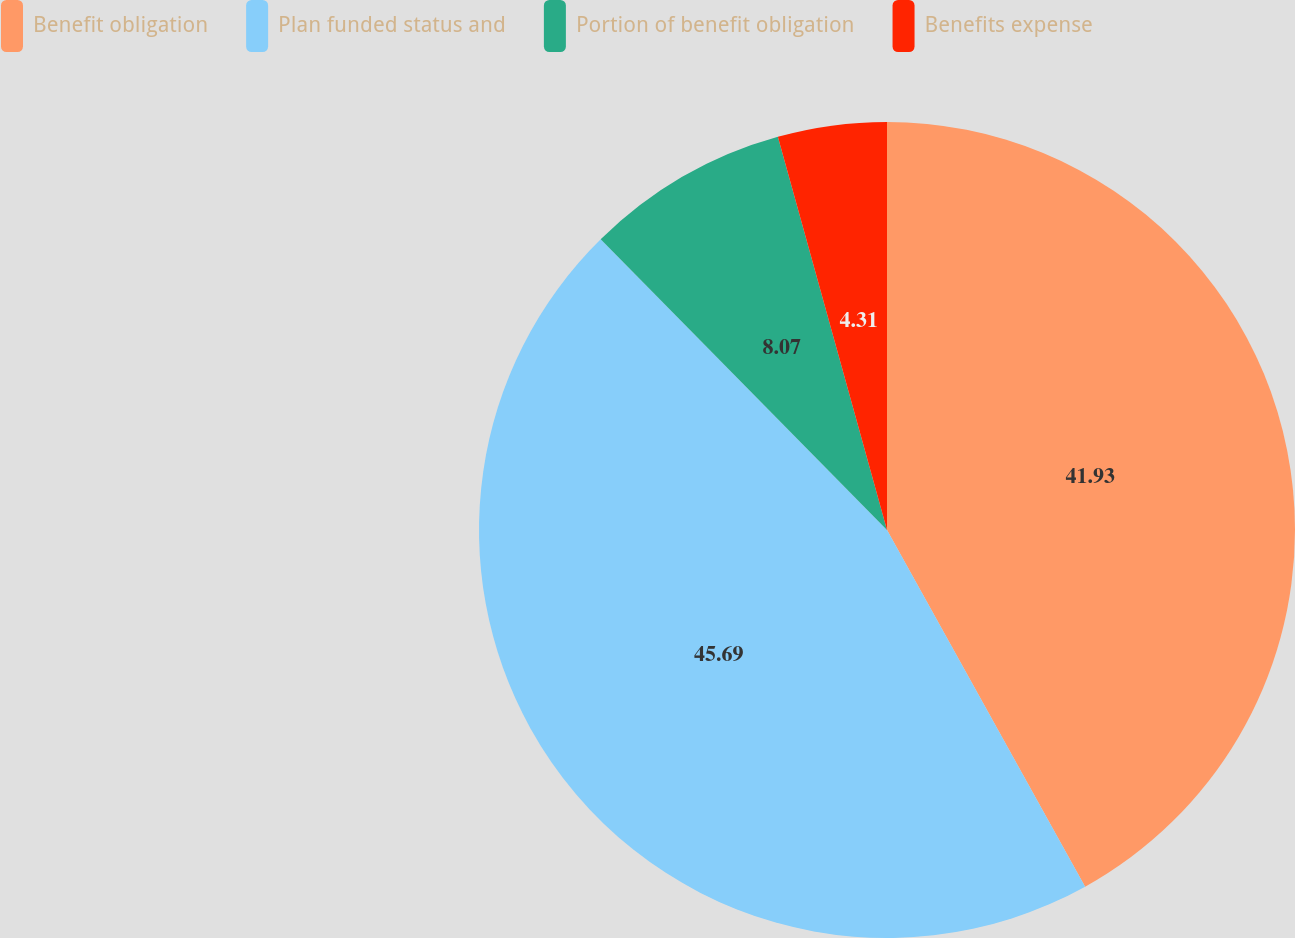Convert chart. <chart><loc_0><loc_0><loc_500><loc_500><pie_chart><fcel>Benefit obligation<fcel>Plan funded status and<fcel>Portion of benefit obligation<fcel>Benefits expense<nl><fcel>41.93%<fcel>45.69%<fcel>8.07%<fcel>4.31%<nl></chart> 